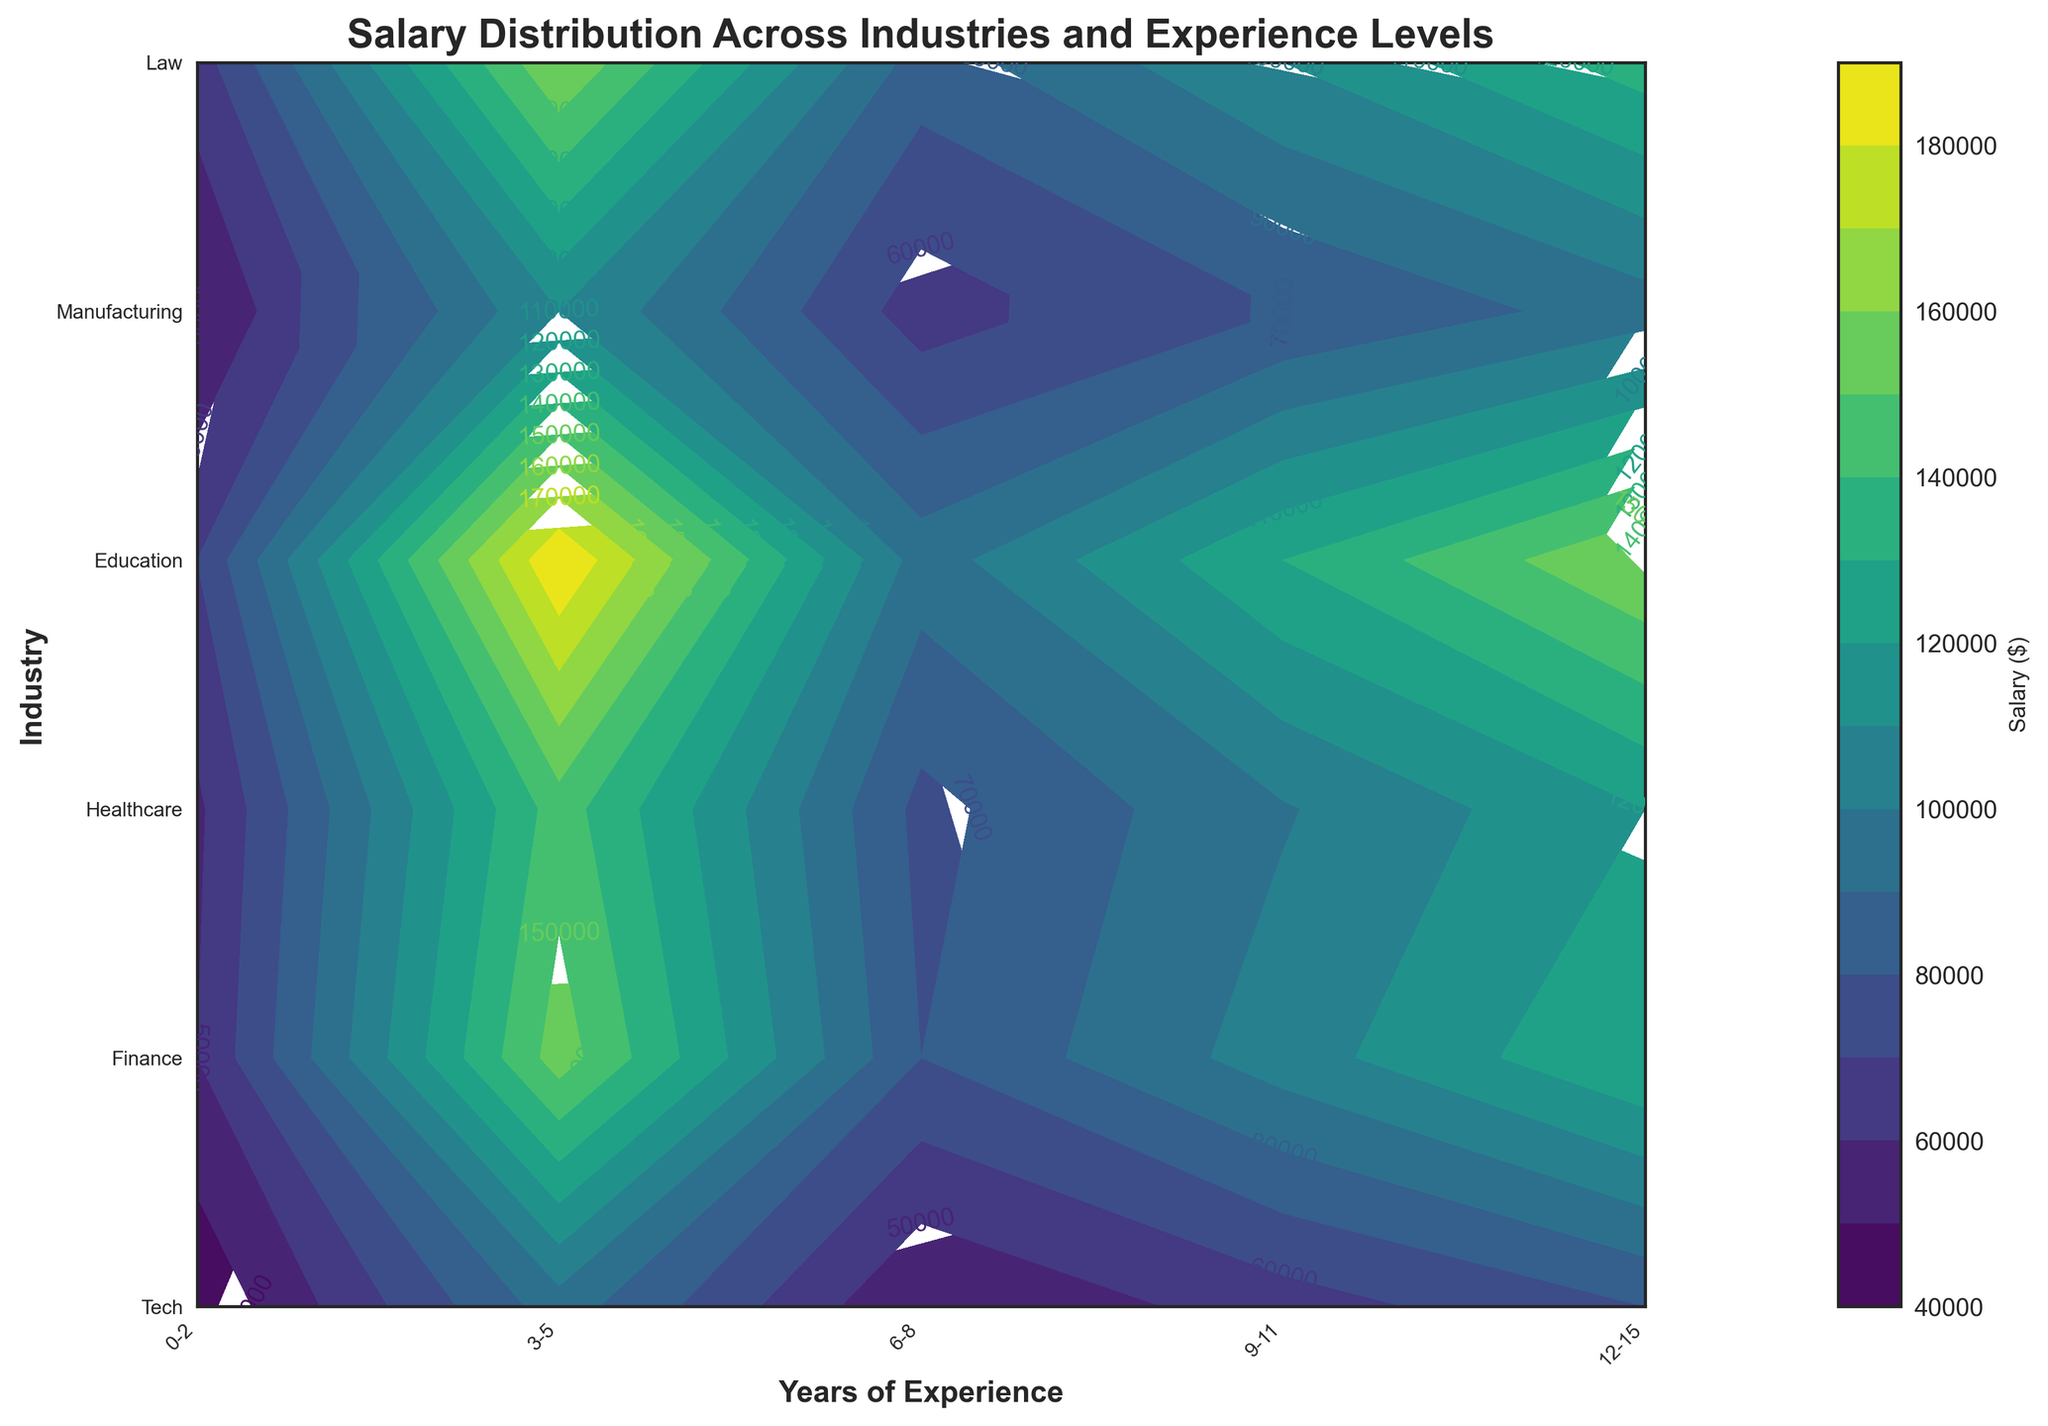What does the title of the figure say? The title is generally found at the top of the figure and summarizes the main topic of the visualization. The title here indicates the relationship being visualized.
Answer: Salary Distribution Across Industries and Experience Levels Which industry shows the highest salary for 12-15 years of experience? Locate the x-axis label for the 12-15 years of experience range, then find the highest contour level on that vertical line. Check the corresponding y-axis label for the industry.
Answer: Law What is the approximate salary for someone with 6-8 years of experience in the Healthcare industry? Find the position of 6-8 years on the x-axis and the Healthcare industry on the y-axis. Identify the contour label closest to their intersection point.
Answer: $99,000 Compare the salary ranges for 0-2 years of experience in Tech and Education industries. Which one is higher? Check the contour labels for the intersections of the 0-2 years of experience with Tech and Education industries. Compare the values.
Answer: Tech How do salaries in Finance compare between the 3-5 and 9-11 years of experience ranges? Locate the Finance industry on the y-axis and find the corresponding salaries for 3-5 and 9-11 years of experience on the x-axis by checking the contour labels.
Answer: $80,000 and $130,000, respectively Which industry has the least salary increment from the 0-2 years range to the 3-5 years range? For each industry, compare the salaries in the ranges 0-2 and 3-5 years. Calculate the differences and determine the smallest value.
Answer: Education What is the color range used in the contour plot for indicating salary levels, and what do the different shades imply? Refer to the color bar legend to understand the spectrum of colors from light to dark, representing different salary levels.
Answer: Varying from lighter to darker shades with increasing salary For someone transitioning from Education to Manufacturing with 6-8 years of experience, how much salary increment would they expect? Check the contour label for salaries in both Education and Manufacturing industries for the 6-8 years of experience range. Calculate the difference.
Answer: $15,000 increment Which industry shows the most rapid salary growth over the entire experience range? Evaluate the progression of contour labels from 0-2 to 12-15 years for each industry and determine the industry with the steepest increase.
Answer: Law Is there any industry where the salary plateaus or grows very slowly after a certain number of years of experience? Analyze the contour labels across the years of experience for each industry to identify any region where the salary remains almost constant.
Answer: Healthcare and Manufacturing 